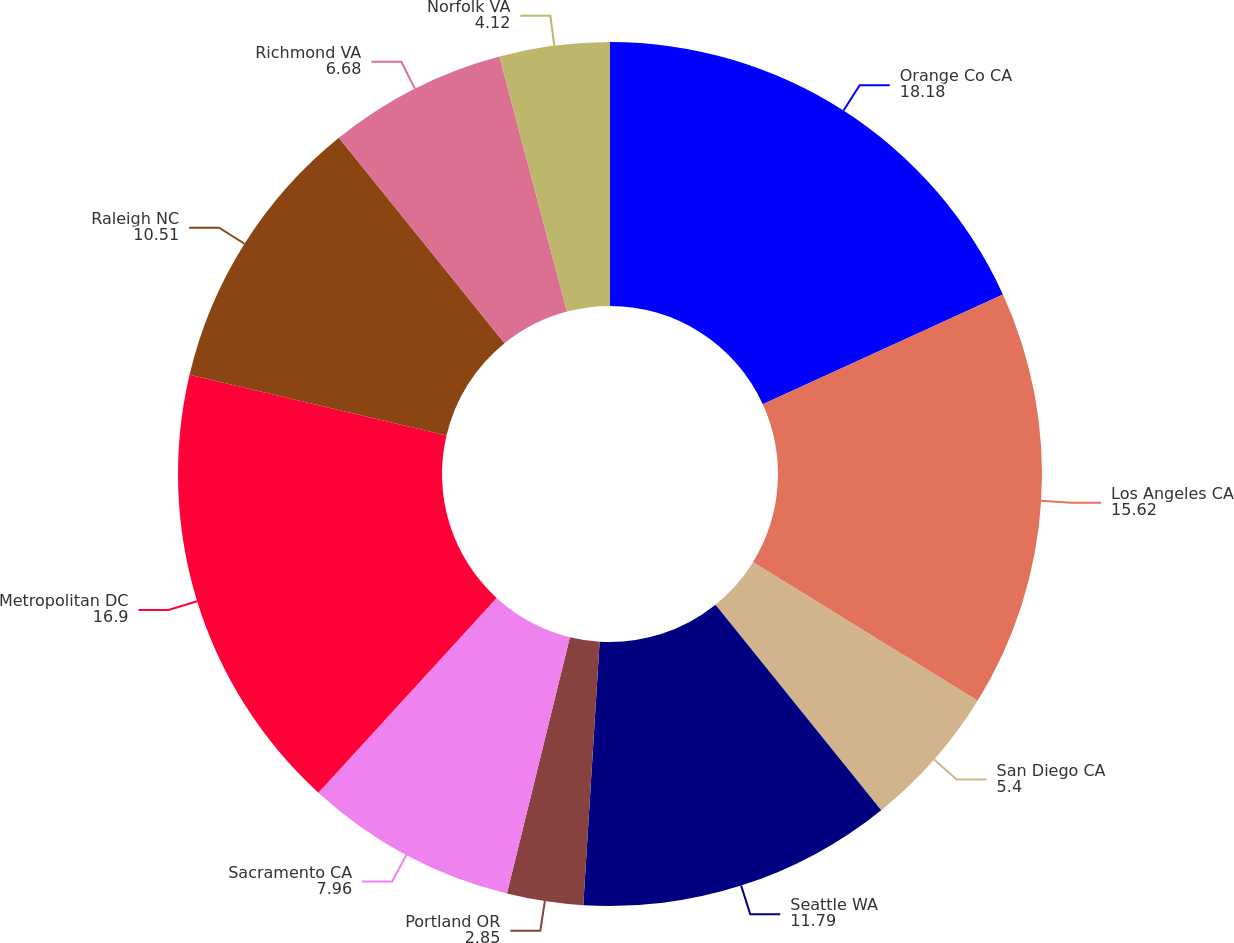Convert chart. <chart><loc_0><loc_0><loc_500><loc_500><pie_chart><fcel>Orange Co CA<fcel>Los Angeles CA<fcel>San Diego CA<fcel>Seattle WA<fcel>Portland OR<fcel>Sacramento CA<fcel>Metropolitan DC<fcel>Raleigh NC<fcel>Richmond VA<fcel>Norfolk VA<nl><fcel>18.18%<fcel>15.62%<fcel>5.4%<fcel>11.79%<fcel>2.85%<fcel>7.96%<fcel>16.9%<fcel>10.51%<fcel>6.68%<fcel>4.12%<nl></chart> 